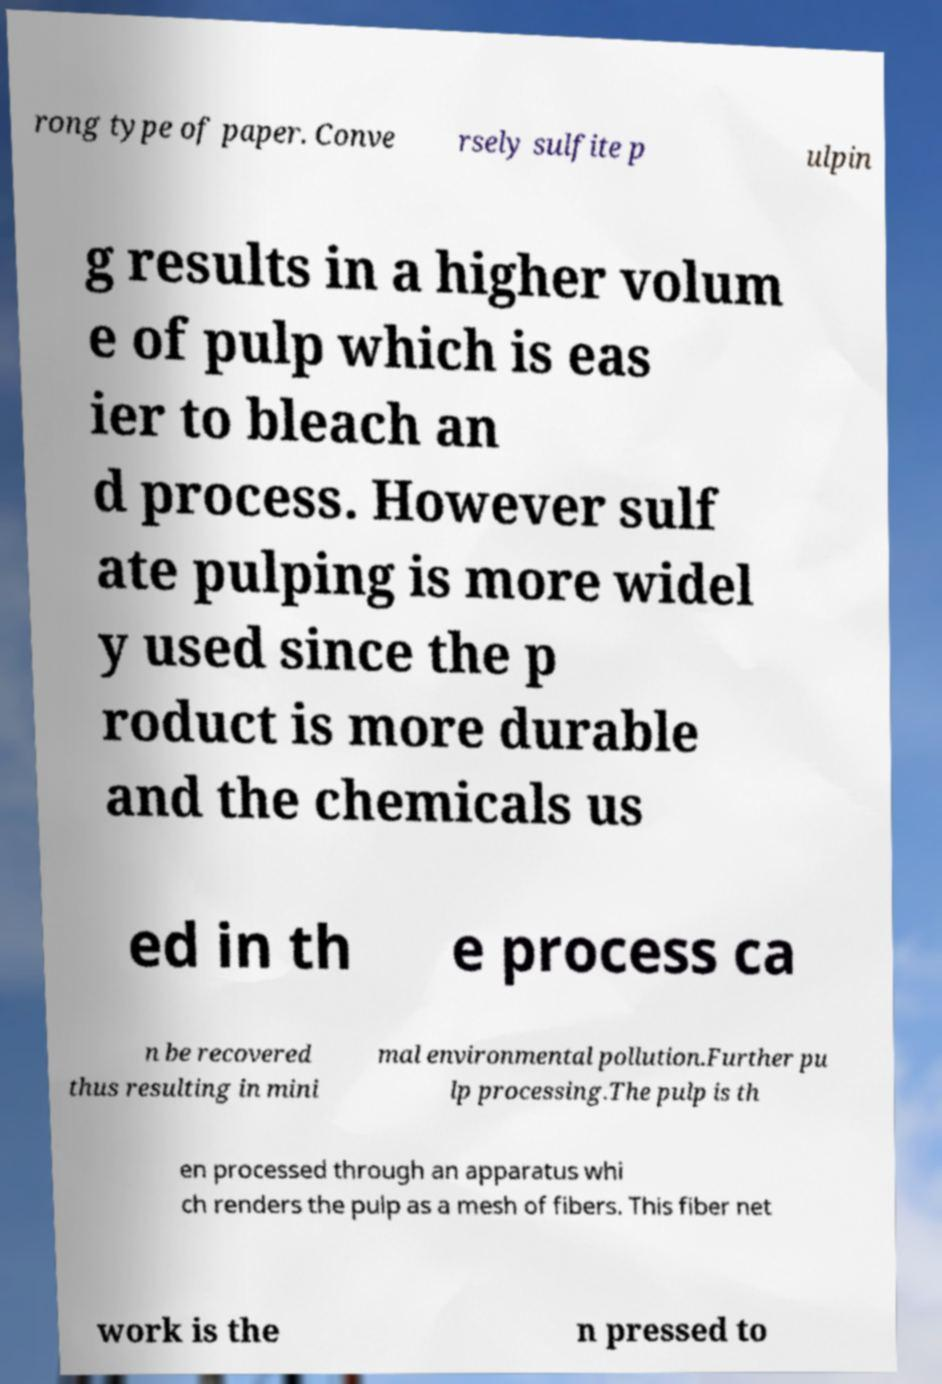For documentation purposes, I need the text within this image transcribed. Could you provide that? rong type of paper. Conve rsely sulfite p ulpin g results in a higher volum e of pulp which is eas ier to bleach an d process. However sulf ate pulping is more widel y used since the p roduct is more durable and the chemicals us ed in th e process ca n be recovered thus resulting in mini mal environmental pollution.Further pu lp processing.The pulp is th en processed through an apparatus whi ch renders the pulp as a mesh of fibers. This fiber net work is the n pressed to 